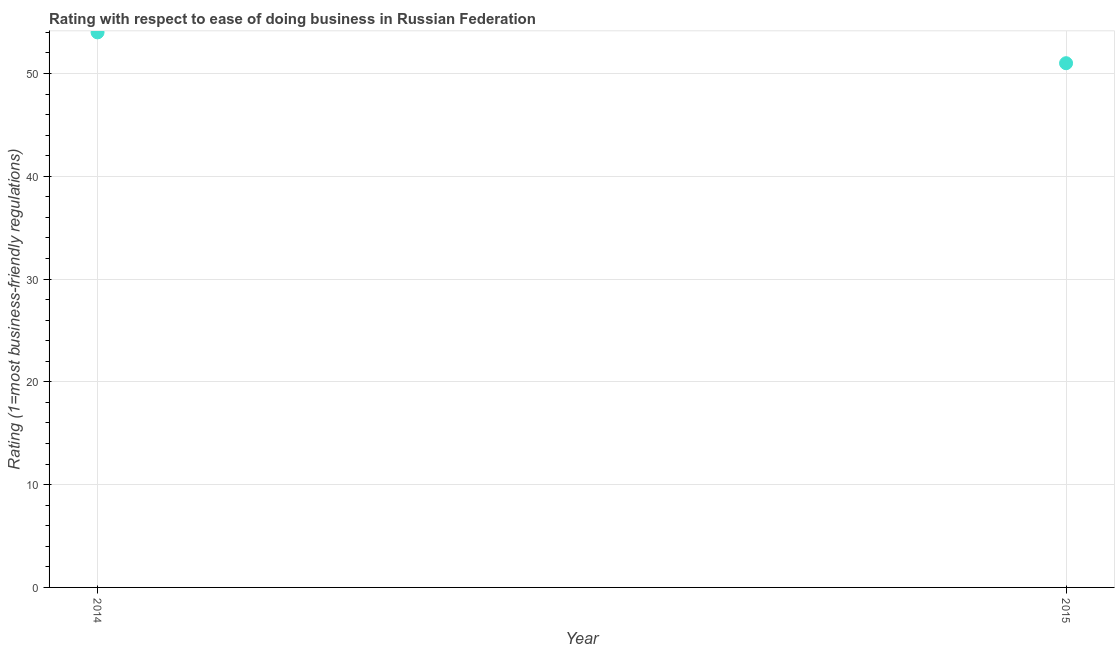What is the ease of doing business index in 2014?
Provide a succinct answer. 54. Across all years, what is the maximum ease of doing business index?
Offer a very short reply. 54. Across all years, what is the minimum ease of doing business index?
Keep it short and to the point. 51. In which year was the ease of doing business index minimum?
Your answer should be compact. 2015. What is the sum of the ease of doing business index?
Give a very brief answer. 105. What is the difference between the ease of doing business index in 2014 and 2015?
Provide a short and direct response. 3. What is the average ease of doing business index per year?
Offer a very short reply. 52.5. What is the median ease of doing business index?
Offer a very short reply. 52.5. In how many years, is the ease of doing business index greater than 36 ?
Provide a short and direct response. 2. What is the ratio of the ease of doing business index in 2014 to that in 2015?
Your answer should be very brief. 1.06. In how many years, is the ease of doing business index greater than the average ease of doing business index taken over all years?
Give a very brief answer. 1. Does the ease of doing business index monotonically increase over the years?
Make the answer very short. No. How many years are there in the graph?
Your answer should be compact. 2. What is the title of the graph?
Ensure brevity in your answer.  Rating with respect to ease of doing business in Russian Federation. What is the label or title of the X-axis?
Give a very brief answer. Year. What is the label or title of the Y-axis?
Give a very brief answer. Rating (1=most business-friendly regulations). What is the Rating (1=most business-friendly regulations) in 2014?
Provide a short and direct response. 54. What is the Rating (1=most business-friendly regulations) in 2015?
Provide a short and direct response. 51. What is the ratio of the Rating (1=most business-friendly regulations) in 2014 to that in 2015?
Your answer should be compact. 1.06. 